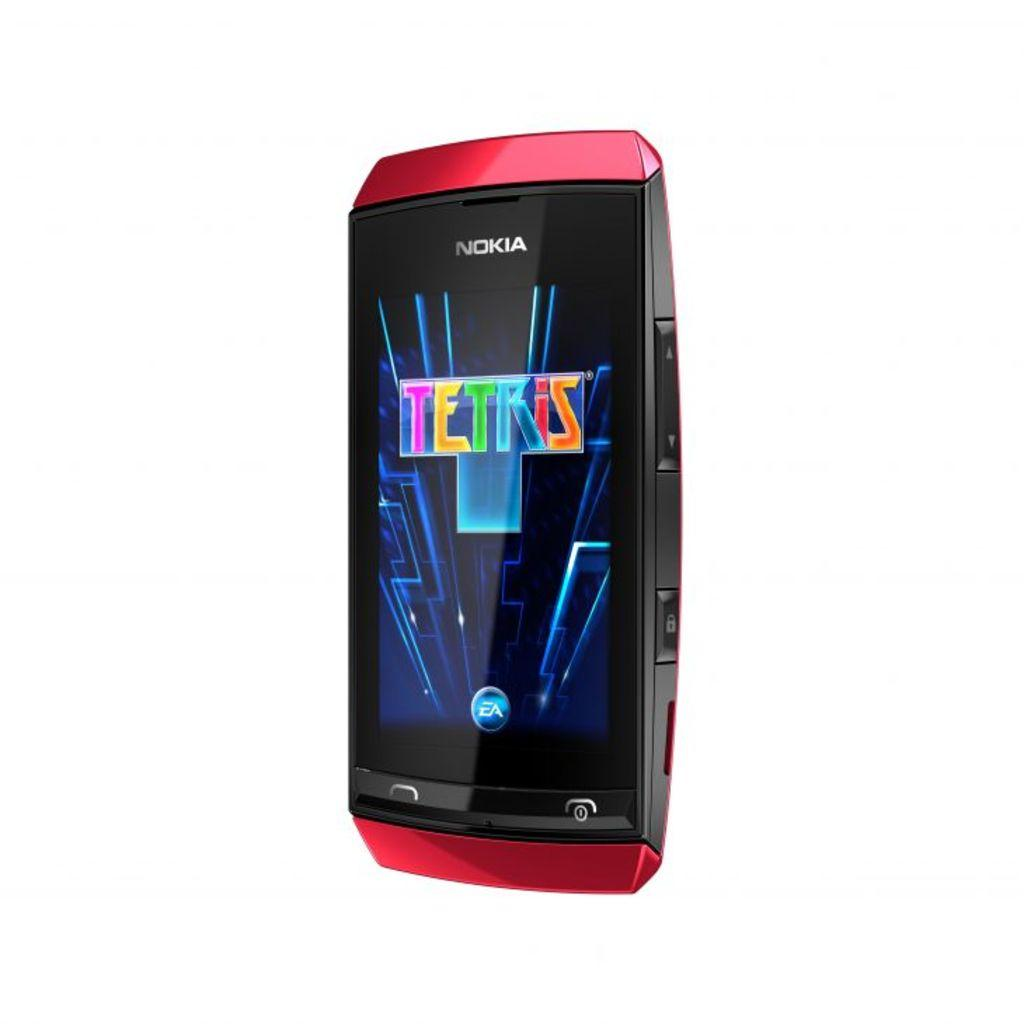<image>
Relay a brief, clear account of the picture shown. A Nokia brand phone is displaying the title screen for Tetris. 